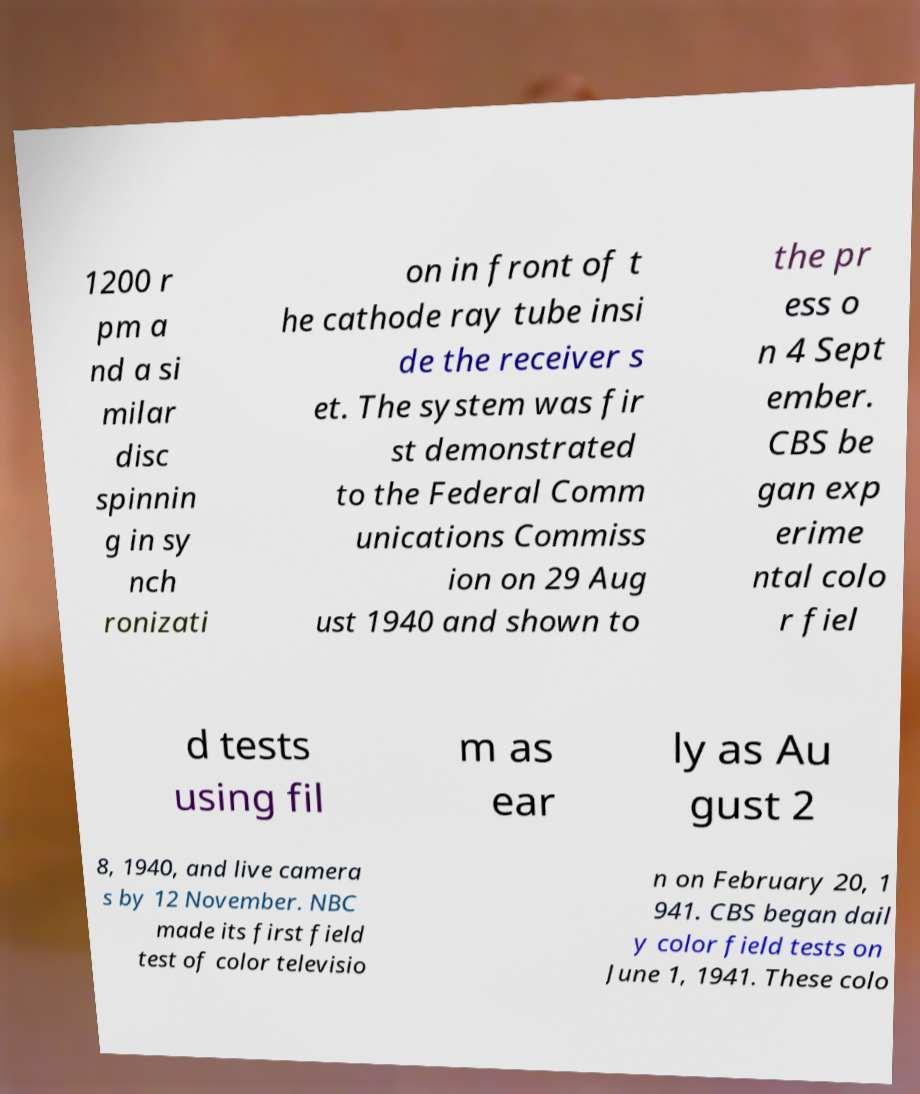Please read and relay the text visible in this image. What does it say? 1200 r pm a nd a si milar disc spinnin g in sy nch ronizati on in front of t he cathode ray tube insi de the receiver s et. The system was fir st demonstrated to the Federal Comm unications Commiss ion on 29 Aug ust 1940 and shown to the pr ess o n 4 Sept ember. CBS be gan exp erime ntal colo r fiel d tests using fil m as ear ly as Au gust 2 8, 1940, and live camera s by 12 November. NBC made its first field test of color televisio n on February 20, 1 941. CBS began dail y color field tests on June 1, 1941. These colo 